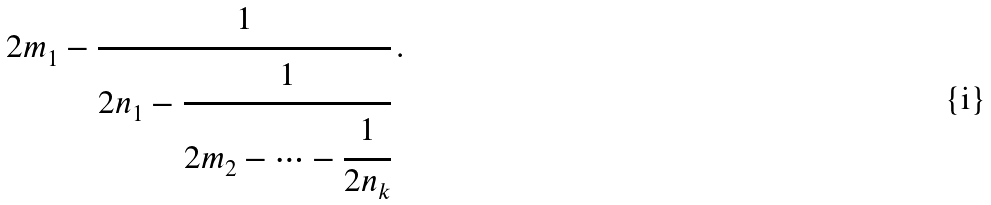<formula> <loc_0><loc_0><loc_500><loc_500>2 m _ { 1 } - \cfrac { 1 } { 2 n _ { 1 } - \cfrac { 1 } { 2 m _ { 2 } - \cdots - \cfrac { 1 } { 2 n _ { k } } } } \, .</formula> 